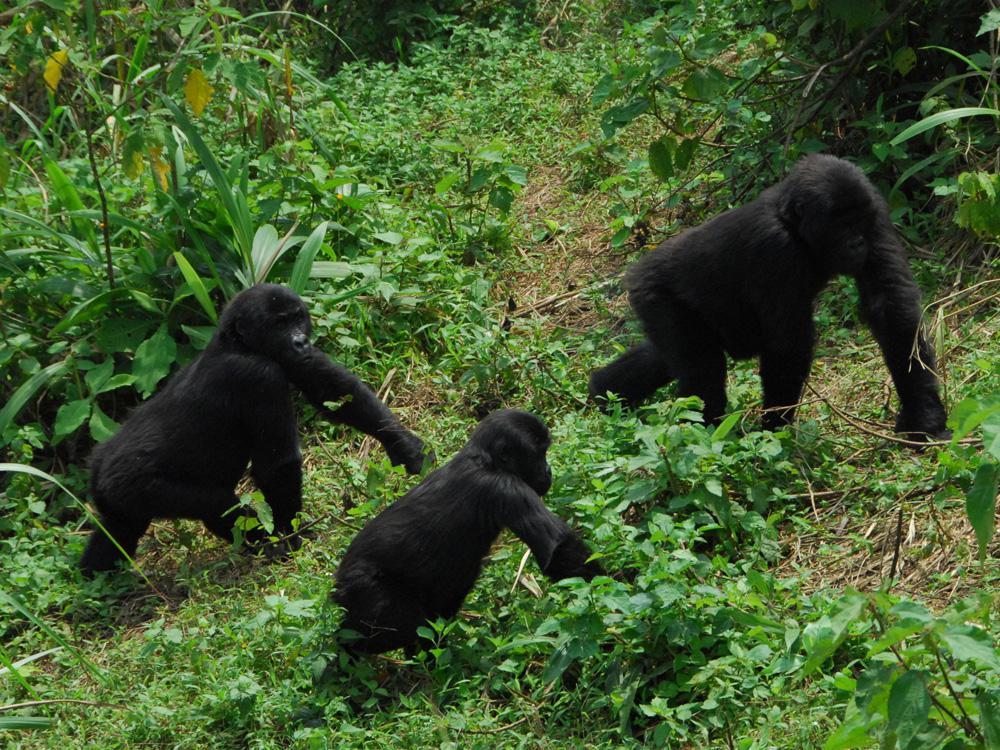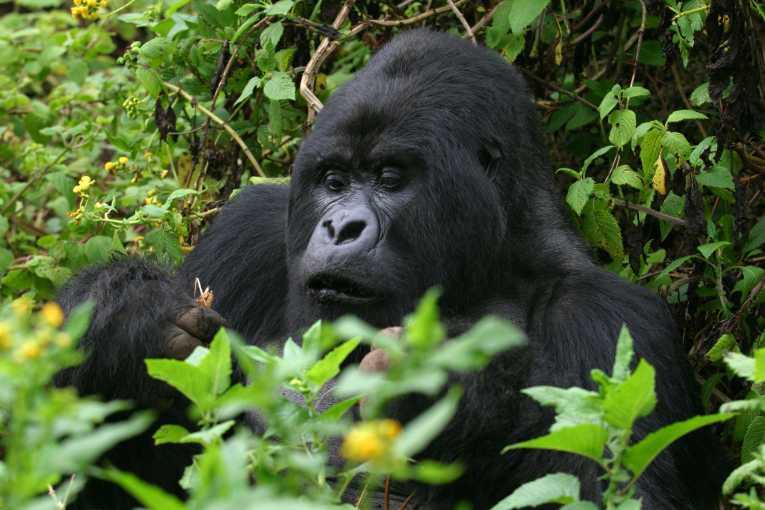The first image is the image on the left, the second image is the image on the right. Analyze the images presented: Is the assertion "One image contains at least eight apes." valid? Answer yes or no. No. The first image is the image on the left, the second image is the image on the right. Examine the images to the left and right. Is the description "A group of four or more gorillas is assembled in the forest." accurate? Answer yes or no. No. 